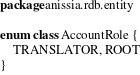<code> <loc_0><loc_0><loc_500><loc_500><_Kotlin_>package anissia.rdb.entity

enum class AccountRole {
    TRANSLATOR, ROOT
}
</code> 